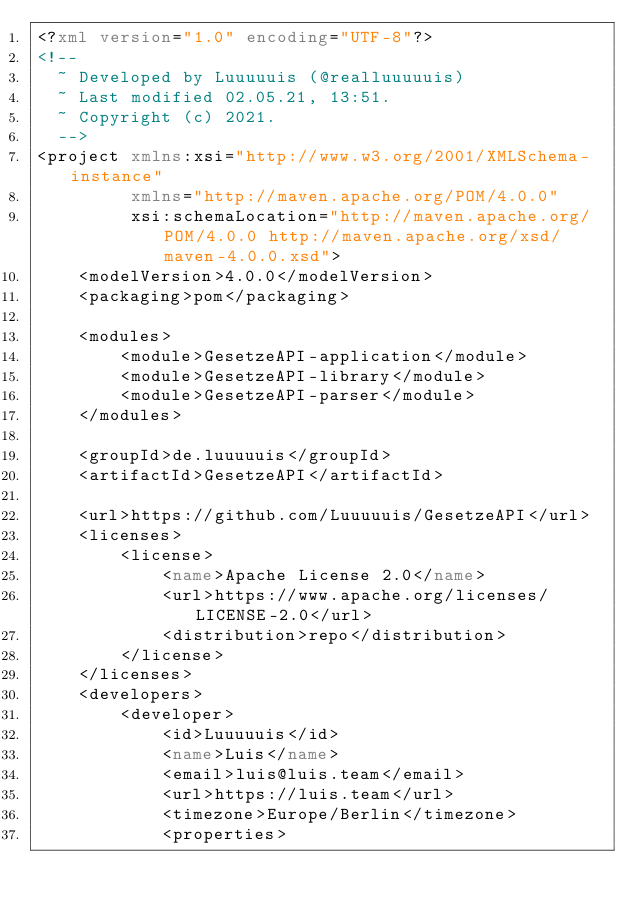Convert code to text. <code><loc_0><loc_0><loc_500><loc_500><_XML_><?xml version="1.0" encoding="UTF-8"?>
<!--
  ~ Developed by Luuuuuis (@realluuuuuis)
  ~ Last modified 02.05.21, 13:51.
  ~ Copyright (c) 2021.
  -->
<project xmlns:xsi="http://www.w3.org/2001/XMLSchema-instance"
         xmlns="http://maven.apache.org/POM/4.0.0"
         xsi:schemaLocation="http://maven.apache.org/POM/4.0.0 http://maven.apache.org/xsd/maven-4.0.0.xsd">
    <modelVersion>4.0.0</modelVersion>
    <packaging>pom</packaging>

    <modules>
        <module>GesetzeAPI-application</module>
        <module>GesetzeAPI-library</module>
        <module>GesetzeAPI-parser</module>
    </modules>

    <groupId>de.luuuuuis</groupId>
    <artifactId>GesetzeAPI</artifactId>

    <url>https://github.com/Luuuuuis/GesetzeAPI</url>
    <licenses>
        <license>
            <name>Apache License 2.0</name>
            <url>https://www.apache.org/licenses/LICENSE-2.0</url>
            <distribution>repo</distribution>
        </license>
    </licenses>
    <developers>
        <developer>
            <id>Luuuuuis</id>
            <name>Luis</name>
            <email>luis@luis.team</email>
            <url>https://luis.team</url>
            <timezone>Europe/Berlin</timezone>
            <properties></code> 